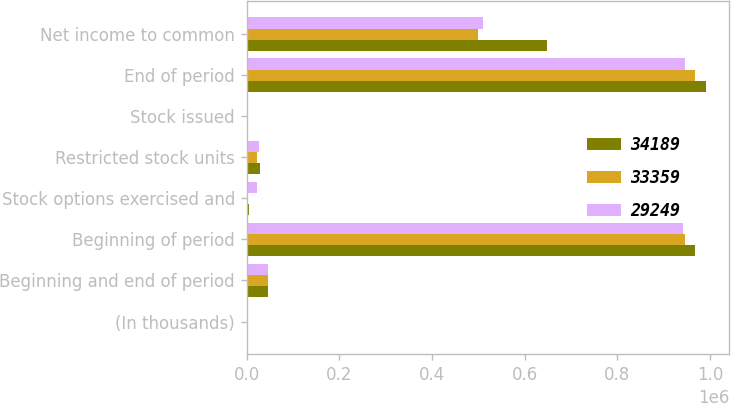Convert chart to OTSL. <chart><loc_0><loc_0><loc_500><loc_500><stacked_bar_chart><ecel><fcel>(In thousands)<fcel>Beginning and end of period<fcel>Beginning of period<fcel>Stock options exercised and<fcel>Restricted stock units<fcel>Stock issued<fcel>End of period<fcel>Net income to common<nl><fcel>34189<fcel>2014<fcel>47024<fcel>967440<fcel>4485<fcel>27966<fcel>591<fcel>991512<fcel>648884<nl><fcel>33359<fcel>2013<fcel>47024<fcel>945166<fcel>1143<fcel>22881<fcel>536<fcel>967440<fcel>499925<nl><fcel>29249<fcel>2012<fcel>47024<fcel>941109<fcel>22125<fcel>25728<fcel>454<fcel>945166<fcel>510592<nl></chart> 